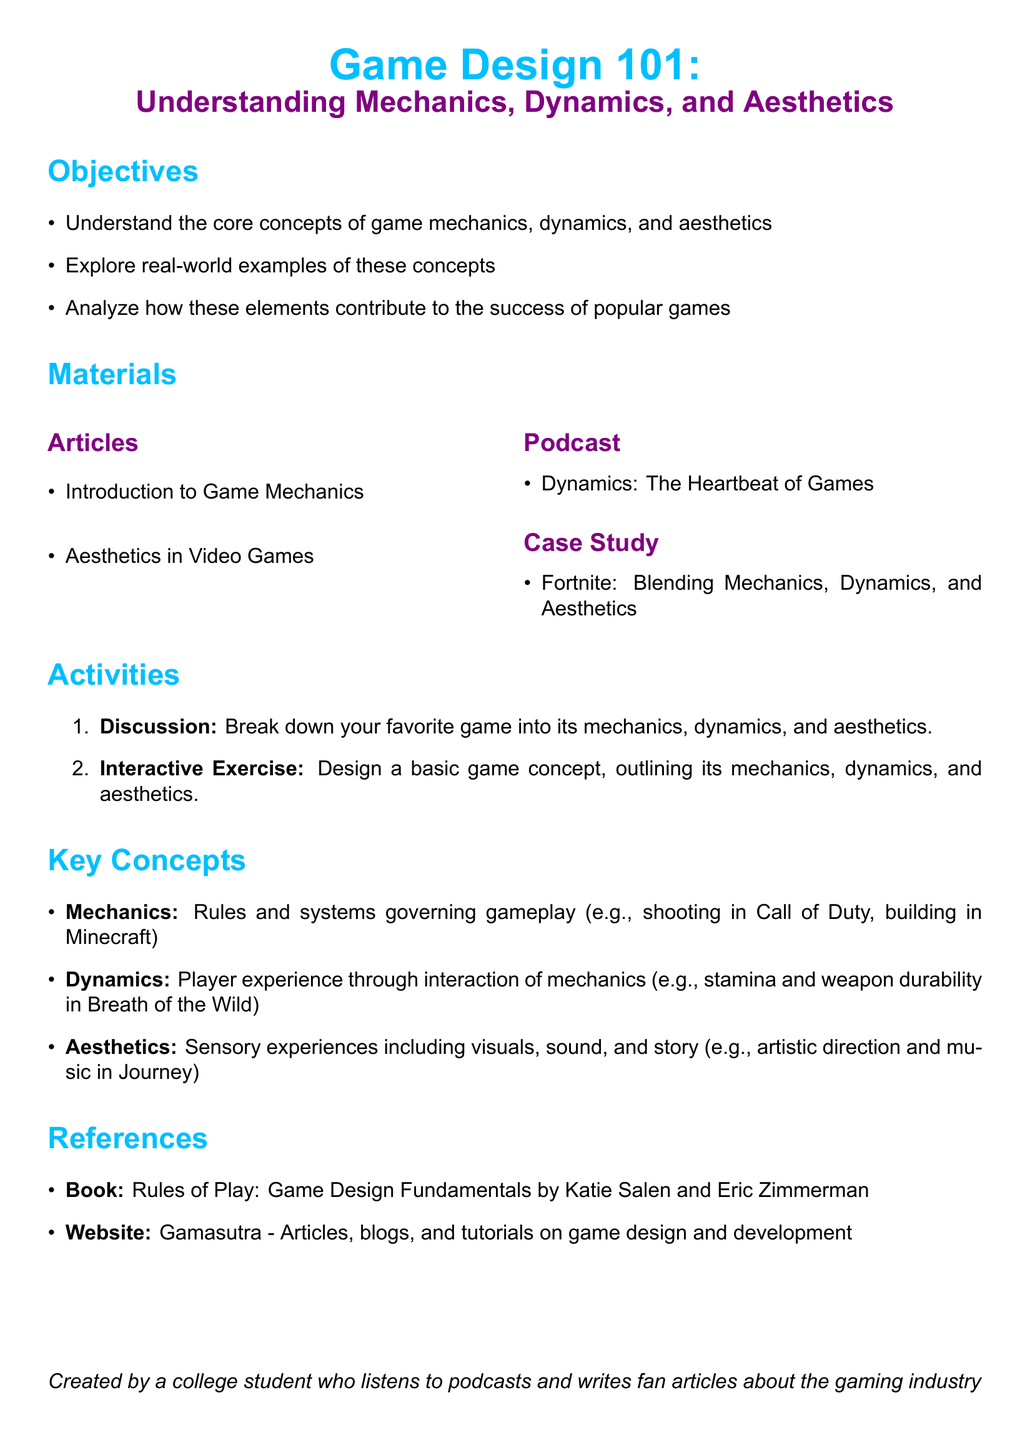What is the title of the lesson plan? The title of the lesson plan is presented prominently at the beginning of the document.
Answer: Game Design 101: Understanding Mechanics, Dynamics, and Aesthetics What are the three main objectives? The objectives are listed as bullet points under the Objectives section.
Answer: Understand the core concepts of game mechanics, dynamics, and aesthetics What case study is included in the materials? The case study is mentioned in the Materials section, providing a specific example.
Answer: Fortnite: Blending Mechanics, Dynamics, and Aesthetics How many activities are listed in the lesson plan? The number of activities is indicated by the numbering in the Activities section.
Answer: 2 What is defined as 'Mechanics' in the key concepts? The definition of mechanics is provided in the Key Concepts section.
Answer: Rules and systems governing gameplay Name the podcast included in the materials. The podcast is specified as part of the Materials section.
Answer: Dynamics: The Heartbeat of Games Who are the authors of the referenced book? The authors' names are provided next to the book title in the References section.
Answer: Katie Salen and Eric Zimmerman What color scheme is used for titles? The colors used for the titles are defined in the document's formatting.
Answer: Gaming blue and gaming purple 